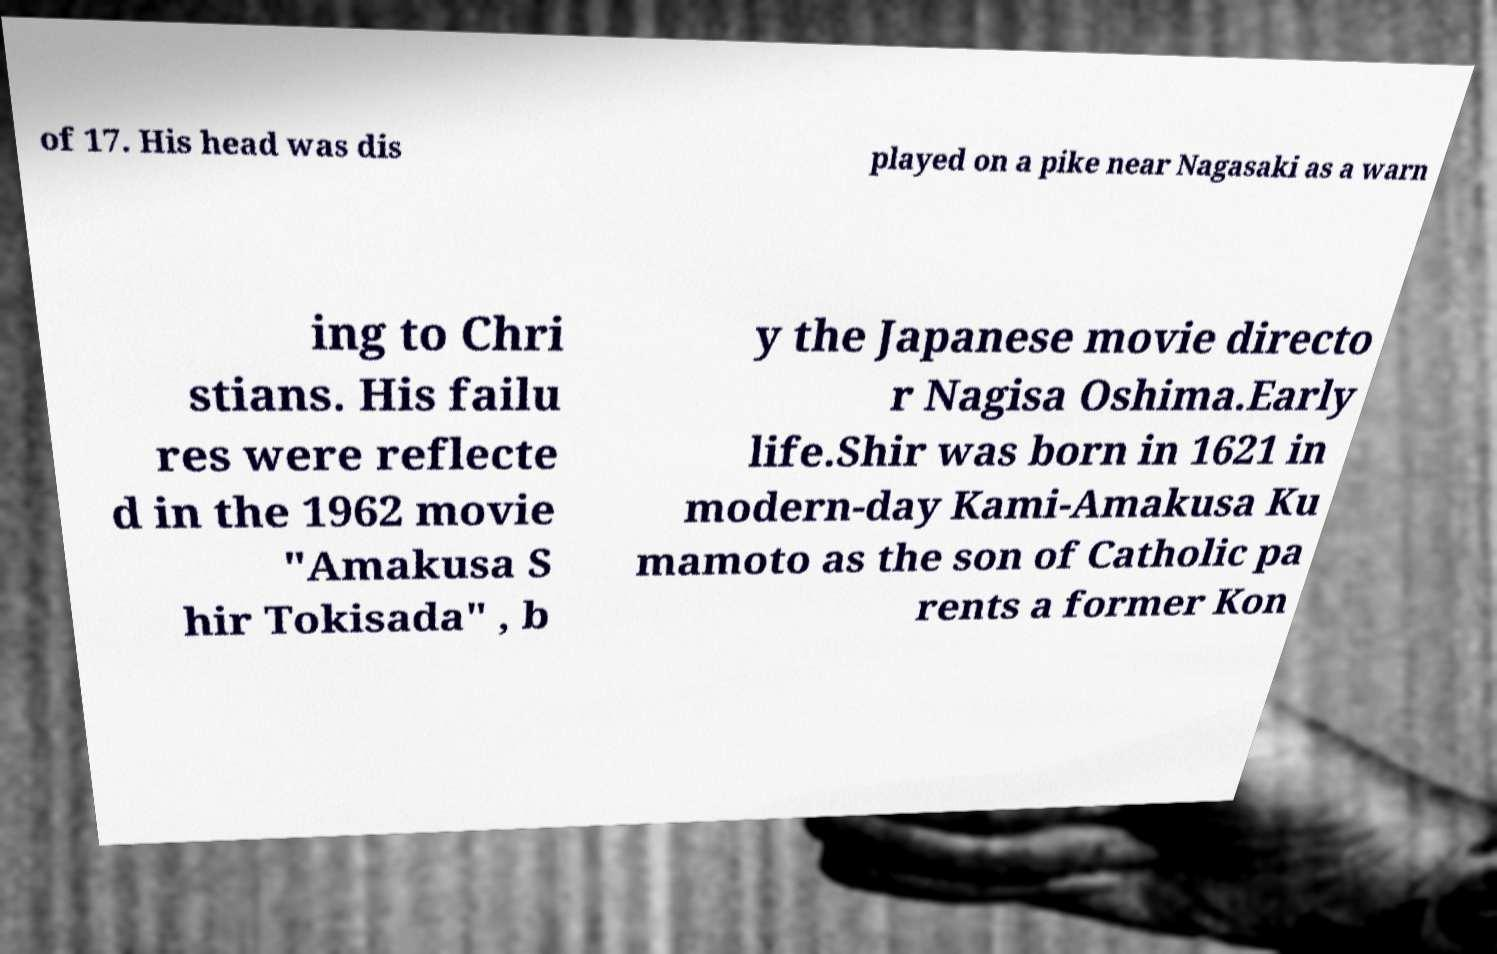What messages or text are displayed in this image? I need them in a readable, typed format. of 17. His head was dis played on a pike near Nagasaki as a warn ing to Chri stians. His failu res were reflecte d in the 1962 movie "Amakusa S hir Tokisada" , b y the Japanese movie directo r Nagisa Oshima.Early life.Shir was born in 1621 in modern-day Kami-Amakusa Ku mamoto as the son of Catholic pa rents a former Kon 